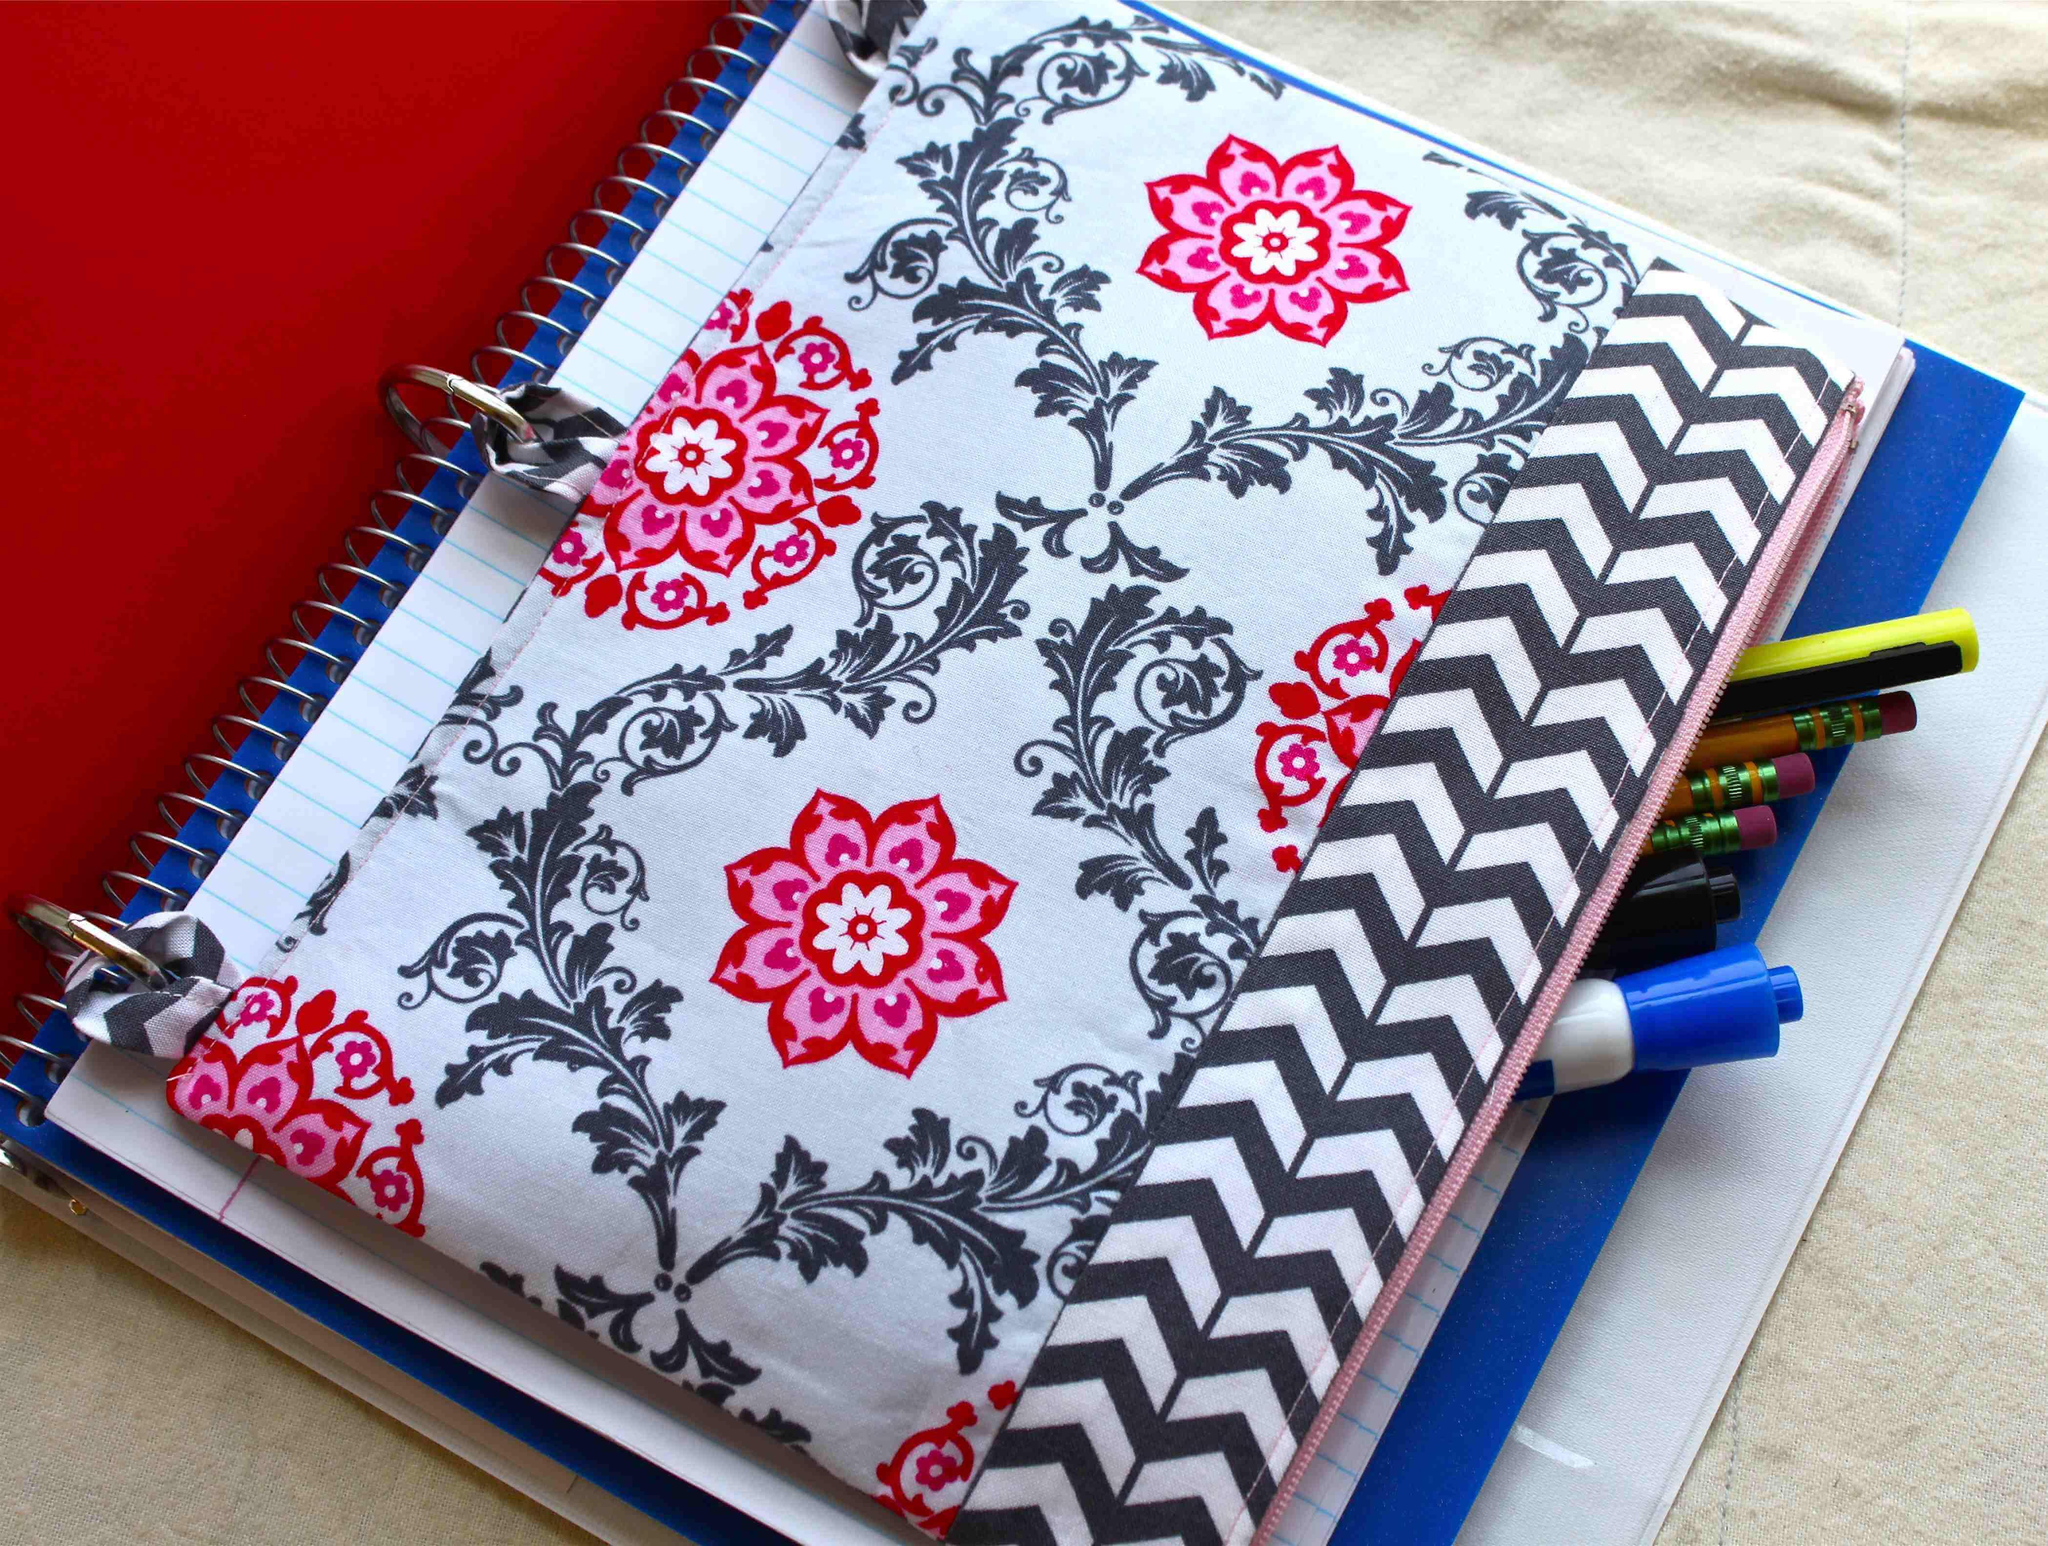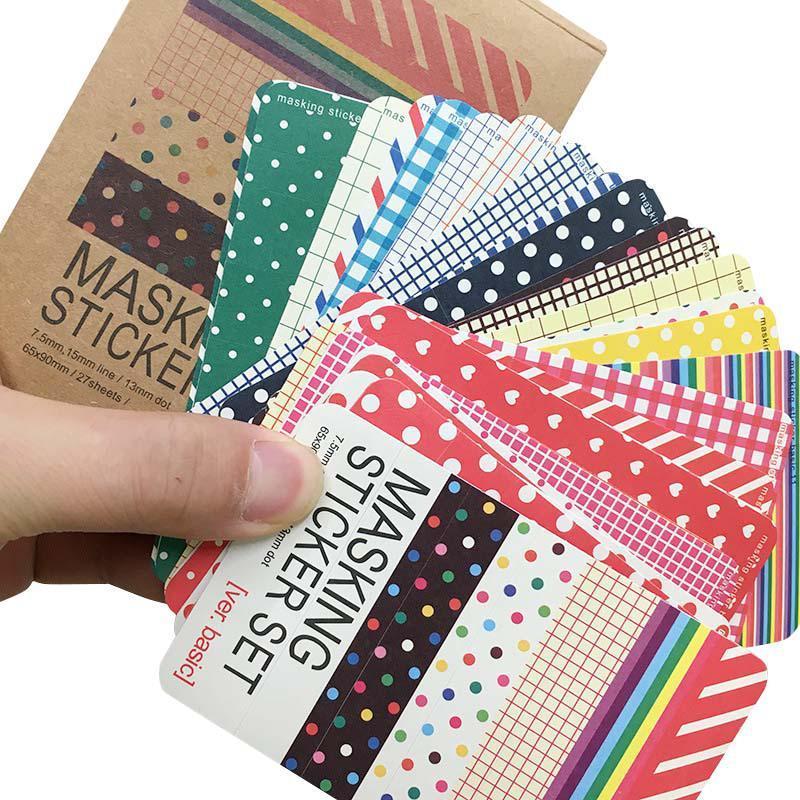The first image is the image on the left, the second image is the image on the right. For the images shown, is this caption "A human hand is touchin a school supply." true? Answer yes or no. Yes. The first image is the image on the left, the second image is the image on the right. Evaluate the accuracy of this statement regarding the images: "A hand is touching at least one rectangular patterned item in one image.". Is it true? Answer yes or no. Yes. 